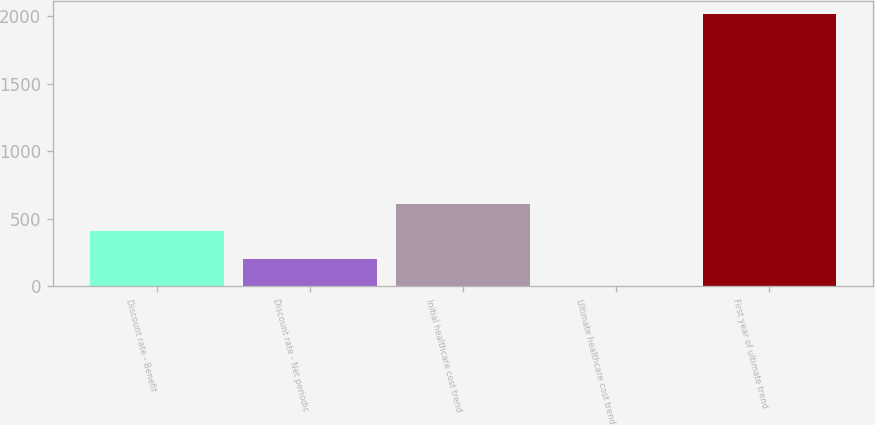Convert chart. <chart><loc_0><loc_0><loc_500><loc_500><bar_chart><fcel>Discount rate - Benefit<fcel>Discount rate - Net periodic<fcel>Initial healthcare cost trend<fcel>Ultimate healthcare cost trend<fcel>First year of ultimate trend<nl><fcel>406.8<fcel>205.9<fcel>607.7<fcel>5<fcel>2014<nl></chart> 